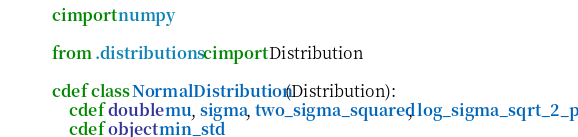<code> <loc_0><loc_0><loc_500><loc_500><_Cython_>cimport numpy

from .distributions cimport Distribution

cdef class NormalDistribution(Distribution):
	cdef double mu, sigma, two_sigma_squared, log_sigma_sqrt_2_pi
	cdef object min_std

</code> 